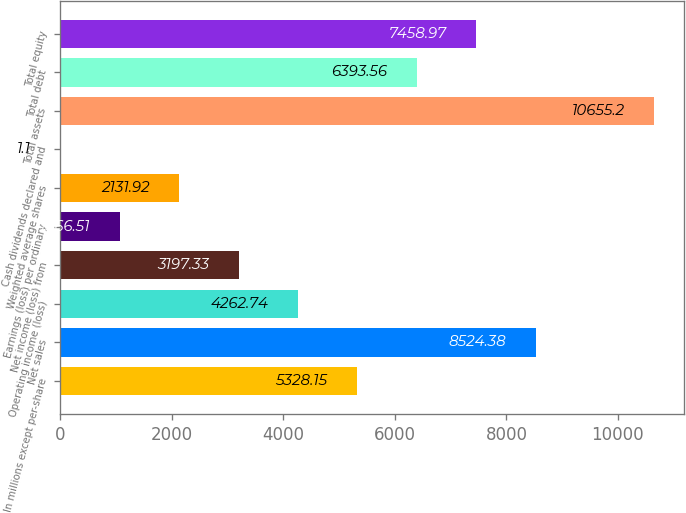Convert chart. <chart><loc_0><loc_0><loc_500><loc_500><bar_chart><fcel>In millions except per-share<fcel>Net sales<fcel>Operating income (loss)<fcel>Net income (loss) from<fcel>Earnings (loss) per ordinary<fcel>Weighted average shares<fcel>Cash dividends declared and<fcel>Total assets<fcel>Total debt<fcel>Total equity<nl><fcel>5328.15<fcel>8524.38<fcel>4262.74<fcel>3197.33<fcel>1066.51<fcel>2131.92<fcel>1.1<fcel>10655.2<fcel>6393.56<fcel>7458.97<nl></chart> 